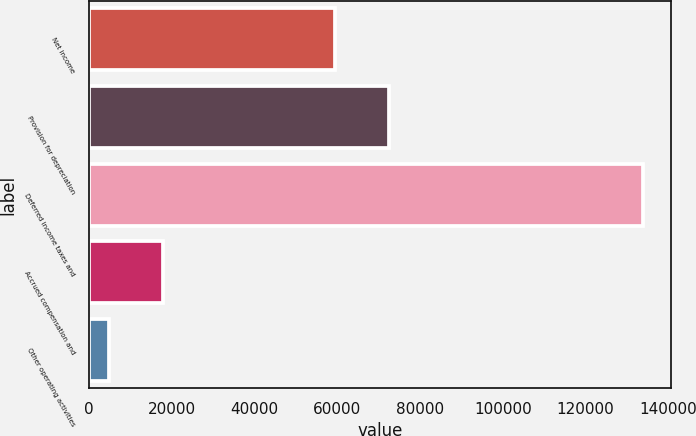Convert chart. <chart><loc_0><loc_0><loc_500><loc_500><bar_chart><fcel>Net income<fcel>Provision for depreciation<fcel>Deferred income taxes and<fcel>Accrued compensation and<fcel>Other operating activities<nl><fcel>59492<fcel>72389.6<fcel>133885<fcel>17806.6<fcel>4909<nl></chart> 